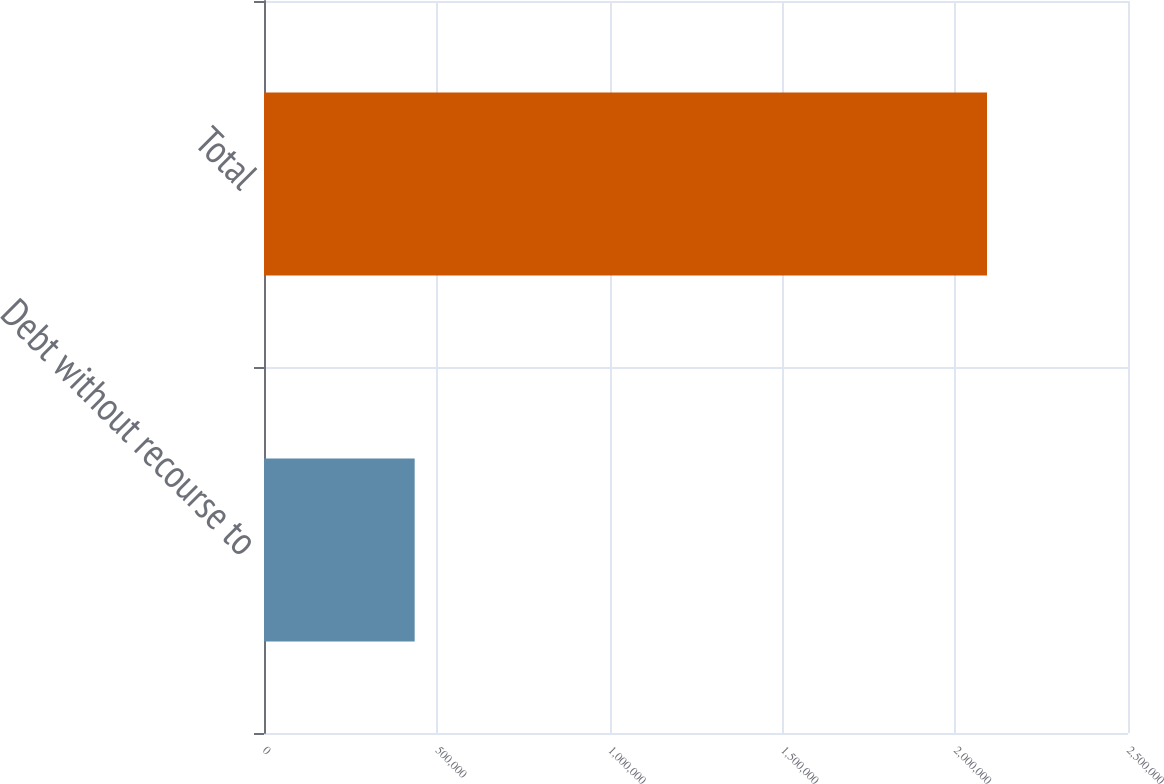<chart> <loc_0><loc_0><loc_500><loc_500><bar_chart><fcel>Debt without recourse to<fcel>Total<nl><fcel>435968<fcel>2.09203e+06<nl></chart> 